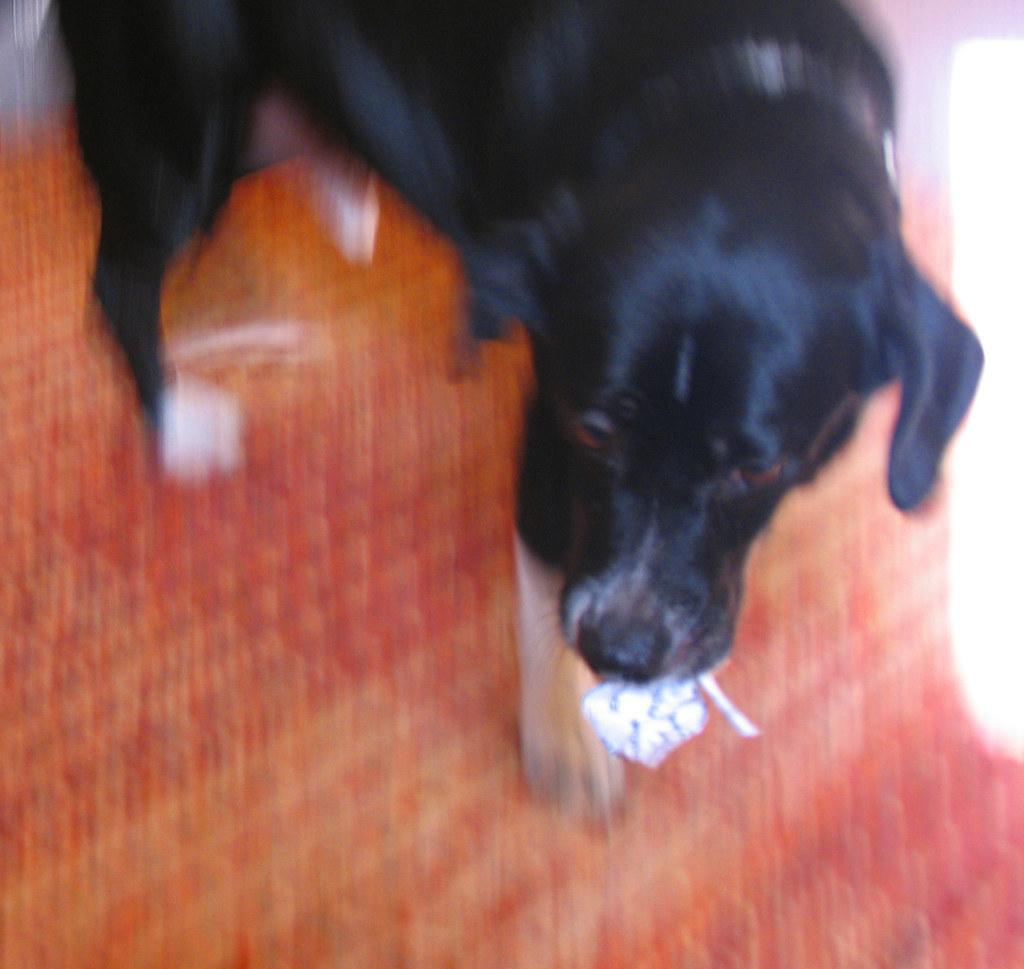What type of animal is in the image? There is a black color dog in the image. What is the dog doing in the image? The dog is holding an item in its mouth. Where is the dog located in the image? The dog is standing on the ground. What type of protest is the dog participating in the image? There is no protest present in the image; it features a dog holding an item in its mouth while standing on the ground. Can you tell me how many boats are docked at the harbor in the image? There is no harbor or boats present in the image; it features a dog holding an item in its mouth while standing on the ground. 